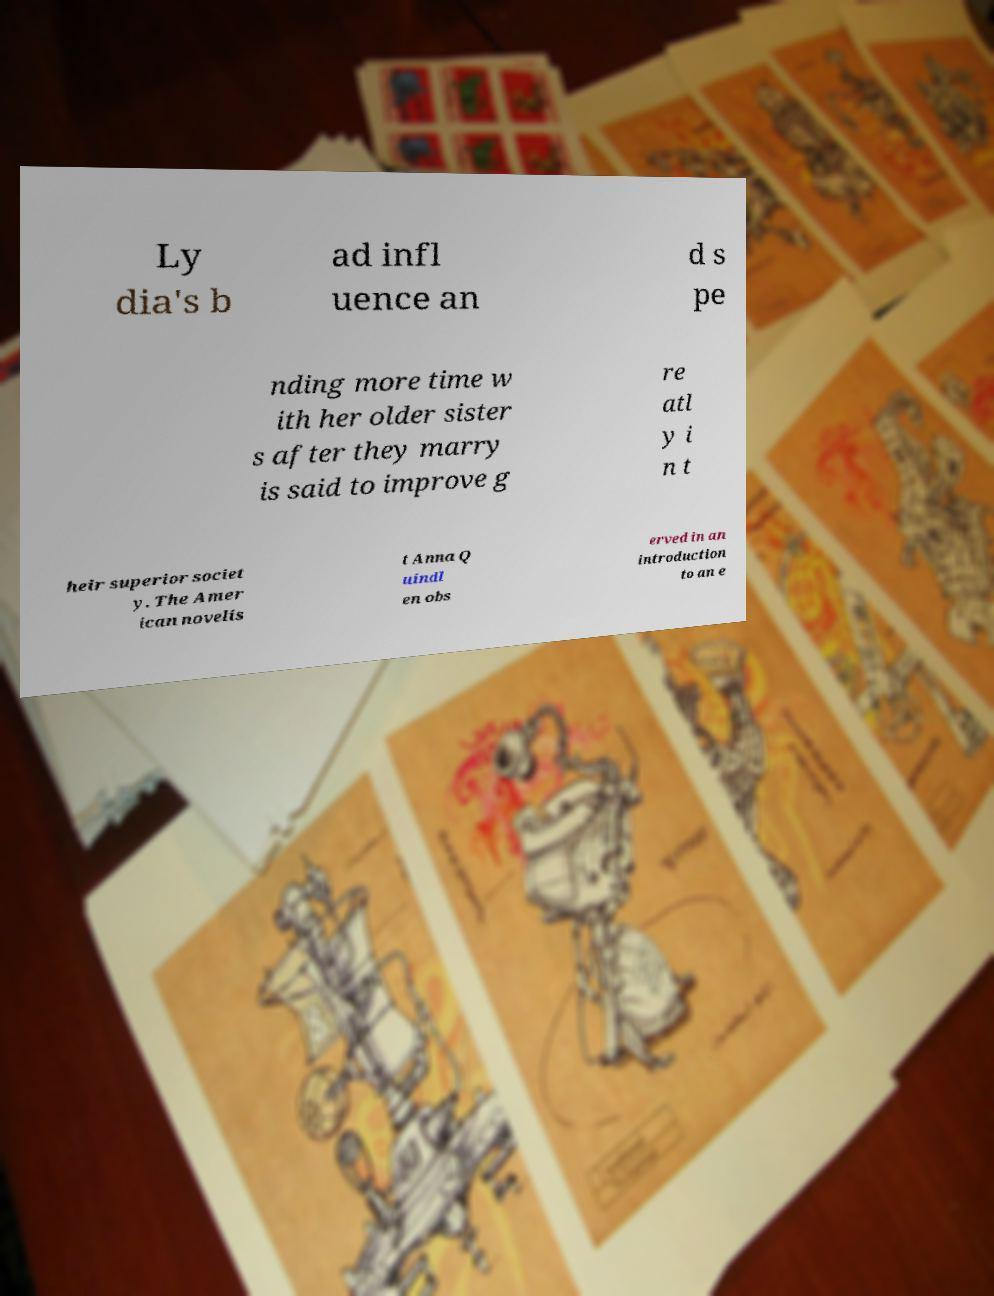Can you read and provide the text displayed in the image?This photo seems to have some interesting text. Can you extract and type it out for me? Ly dia's b ad infl uence an d s pe nding more time w ith her older sister s after they marry is said to improve g re atl y i n t heir superior societ y. The Amer ican novelis t Anna Q uindl en obs erved in an introduction to an e 